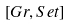Convert formula to latex. <formula><loc_0><loc_0><loc_500><loc_500>[ G r , S e t ]</formula> 